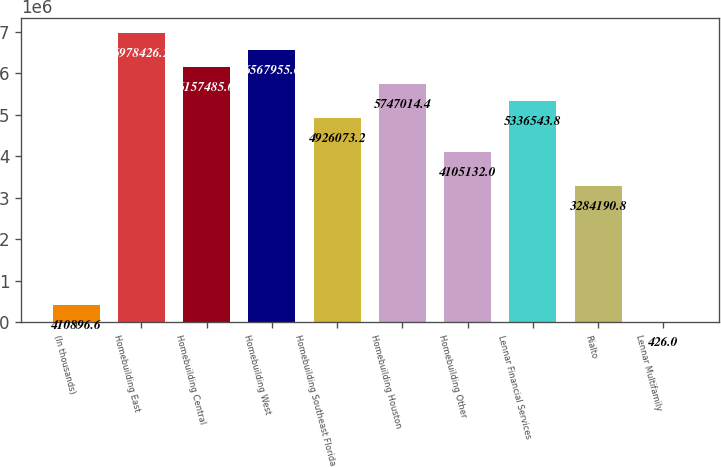<chart> <loc_0><loc_0><loc_500><loc_500><bar_chart><fcel>(In thousands)<fcel>Homebuilding East<fcel>Homebuilding Central<fcel>Homebuilding West<fcel>Homebuilding Southeast Florida<fcel>Homebuilding Houston<fcel>Homebuilding Other<fcel>Lennar Financial Services<fcel>Rialto<fcel>Lennar Multifamily<nl><fcel>410897<fcel>6.97843e+06<fcel>6.15748e+06<fcel>6.56796e+06<fcel>4.92607e+06<fcel>5.74701e+06<fcel>4.10513e+06<fcel>5.33654e+06<fcel>3.28419e+06<fcel>426<nl></chart> 